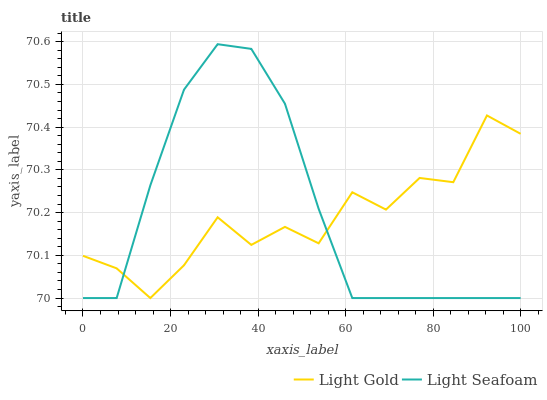Does Light Gold have the minimum area under the curve?
Answer yes or no. Yes. Does Light Seafoam have the maximum area under the curve?
Answer yes or no. Yes. Does Light Gold have the maximum area under the curve?
Answer yes or no. No. Is Light Seafoam the smoothest?
Answer yes or no. Yes. Is Light Gold the roughest?
Answer yes or no. Yes. Is Light Gold the smoothest?
Answer yes or no. No. Does Light Seafoam have the lowest value?
Answer yes or no. Yes. Does Light Seafoam have the highest value?
Answer yes or no. Yes. Does Light Gold have the highest value?
Answer yes or no. No. Does Light Gold intersect Light Seafoam?
Answer yes or no. Yes. Is Light Gold less than Light Seafoam?
Answer yes or no. No. Is Light Gold greater than Light Seafoam?
Answer yes or no. No. 